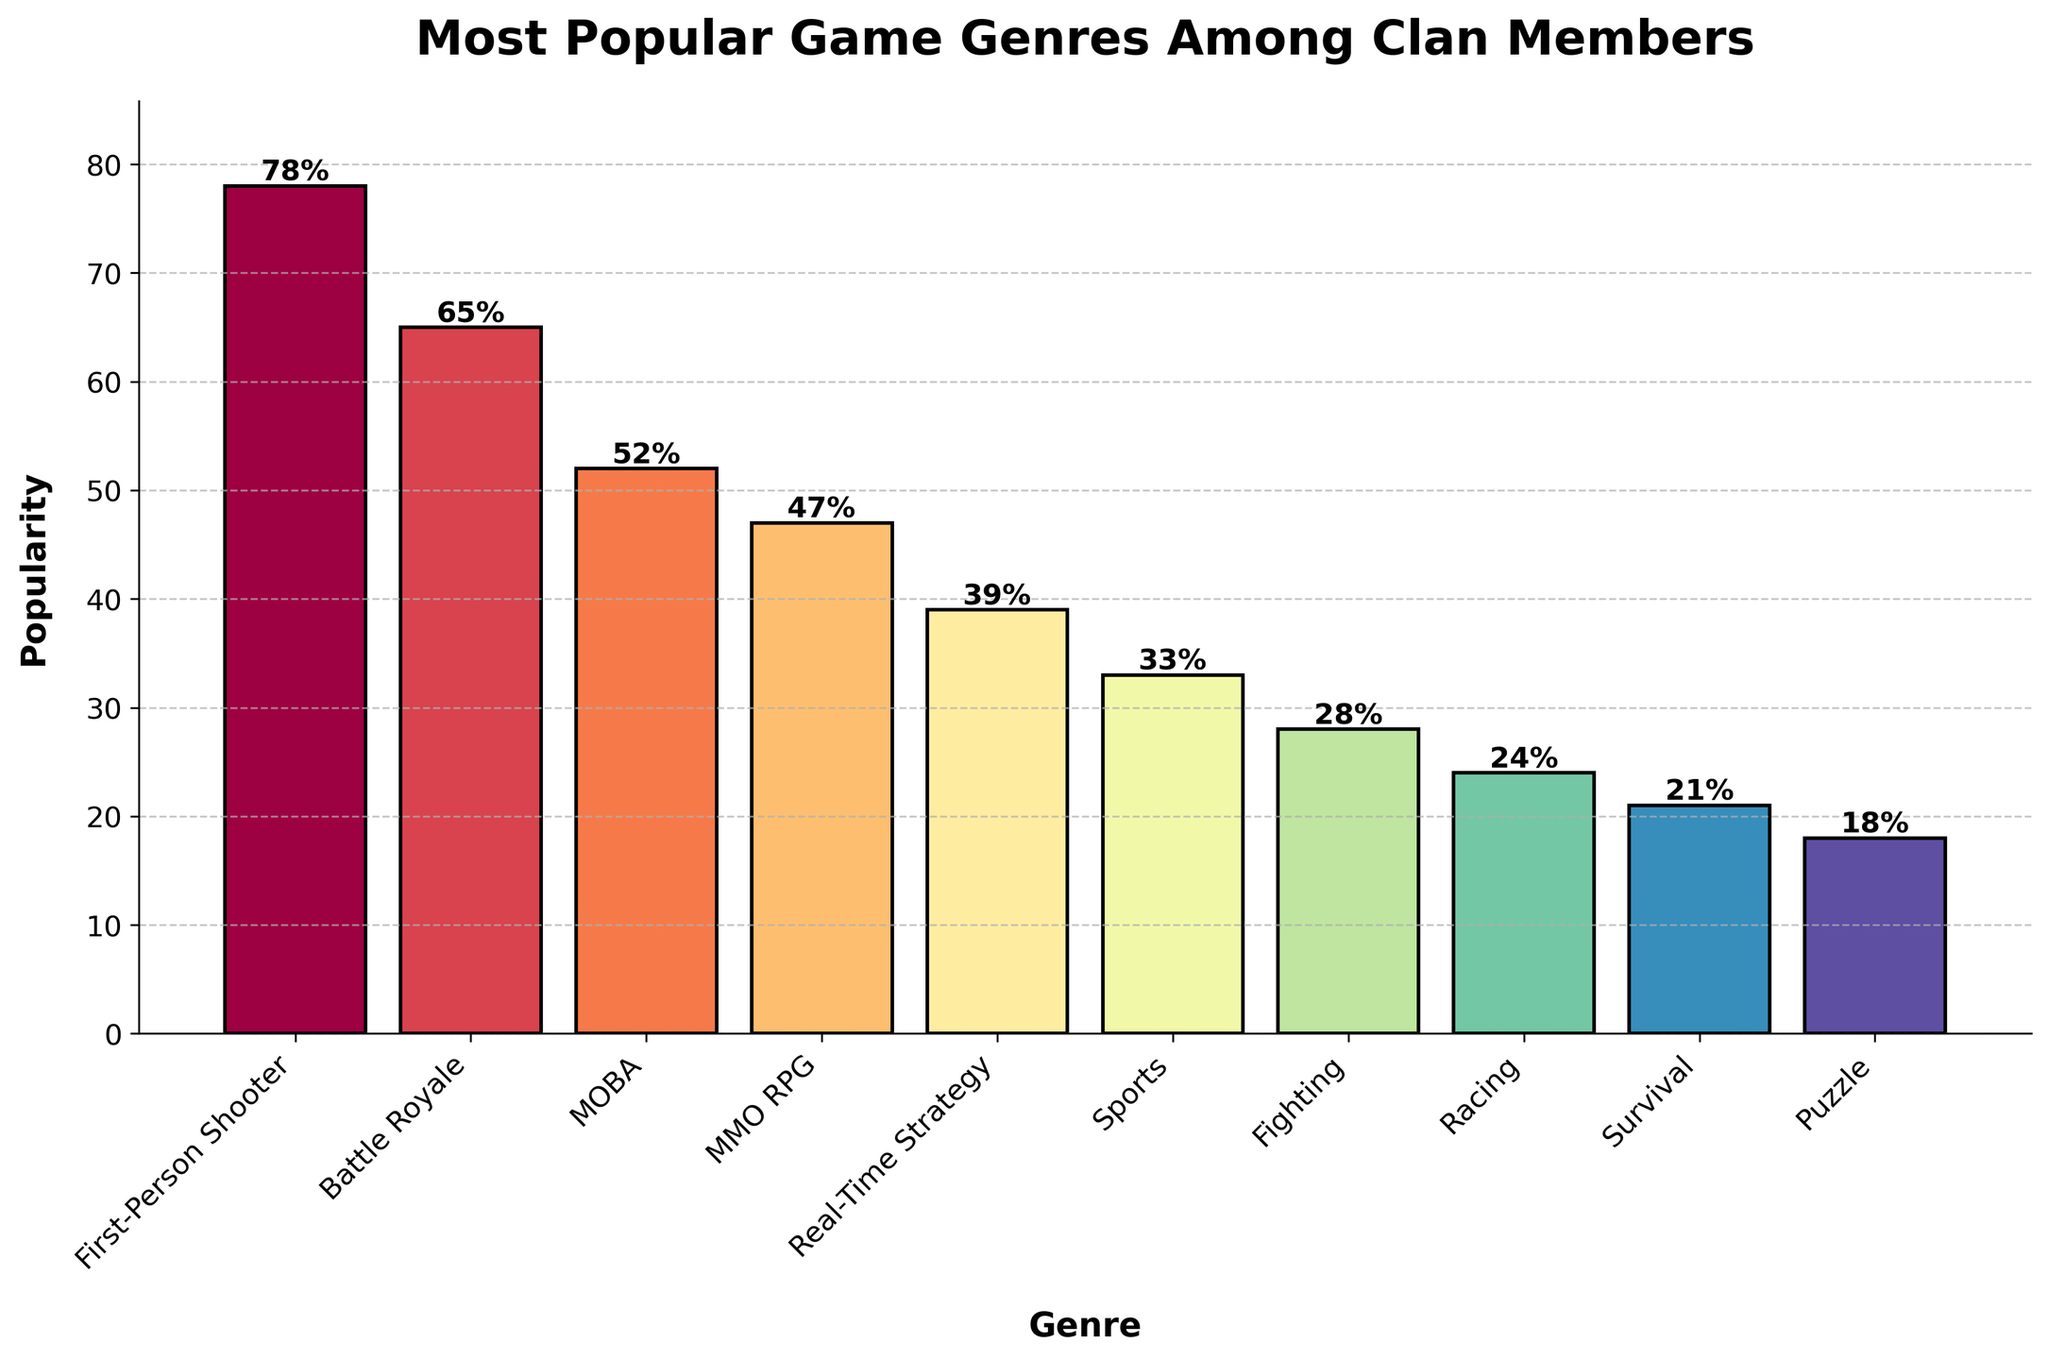Which game genre is the most popular among clan members? The figure shows the height of the bars representing popularity. The highest bar indicates the most popular genre.
Answer: First-Person Shooter Which game genre is the least popular among clan members? The figure shows the height of the bars representing popularity. The shortest bar indicates the least popular genre.
Answer: Puzzle How much more popular are First-Person Shooters compared to Racing games? To find the difference, subtract the popularity of Racing from that of First-Person Shooter: 78 - 24.
Answer: 54 Name two game genres that have a similar level of popularity. By examining the bars of similar height, MOBA and MMO RPG are close in popularity.
Answer: MOBA and MMO RPG What is the average popularity of Battle Royale, MOBA, and Sports genres? Add their popularity values and divide by the number of genres: (65 + 52 + 33) / 3.
Answer: 50 Compare the popularity of MMO RPGs and Sports games. Which one is higher and by how much? By examining the bars, MMO RPG has a popularity of 47, while Sports has 33. The difference is 47 - 33.
Answer: MMO RPG by 14 Which genre has the second-highest popularity, and what is its value? The second tallest bar after the First-Person Shooter represents the second-most popular genre.
Answer: Battle Royale, 65 Are there more clan members preferring Sports or Racing games? Comparing the height of the bars, the Sports bar is taller than the Racing bar.
Answer: Sports What is the combined popularity of the top three game genres? Add the popularity of the top three genres: 78 (First-Person Shooter) + 65 (Battle Royale) + 52 (MOBA).
Answer: 195 Which genre has just slightly more popularity than Real-Time Strategy? Real-Time Strategy has a popularity of 39. The next slightly higher bar is for MMO RPG at 47.
Answer: MMO RPG 